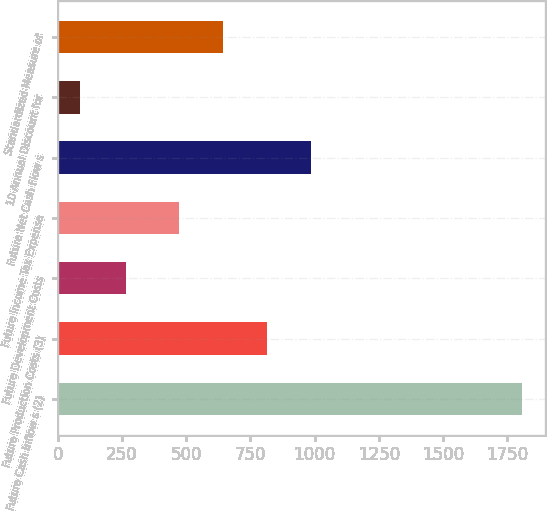<chart> <loc_0><loc_0><loc_500><loc_500><bar_chart><fcel>Future Cash Inflow s (2)<fcel>Future Production Costs (3)<fcel>Future Development Costs<fcel>Future Income Tax Expense<fcel>Future Net Cash Flow s<fcel>10 Annual Discount for<fcel>Standardized Measure of<nl><fcel>1806<fcel>814.8<fcel>267<fcel>471<fcel>986.7<fcel>87<fcel>642.9<nl></chart> 